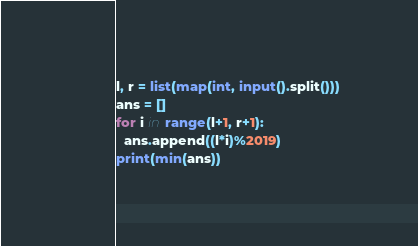<code> <loc_0><loc_0><loc_500><loc_500><_Python_>l, r = list(map(int, input().split()))
ans = []
for i in range(l+1, r+1):
  ans.append((l*i)%2019)
print(min(ans))</code> 